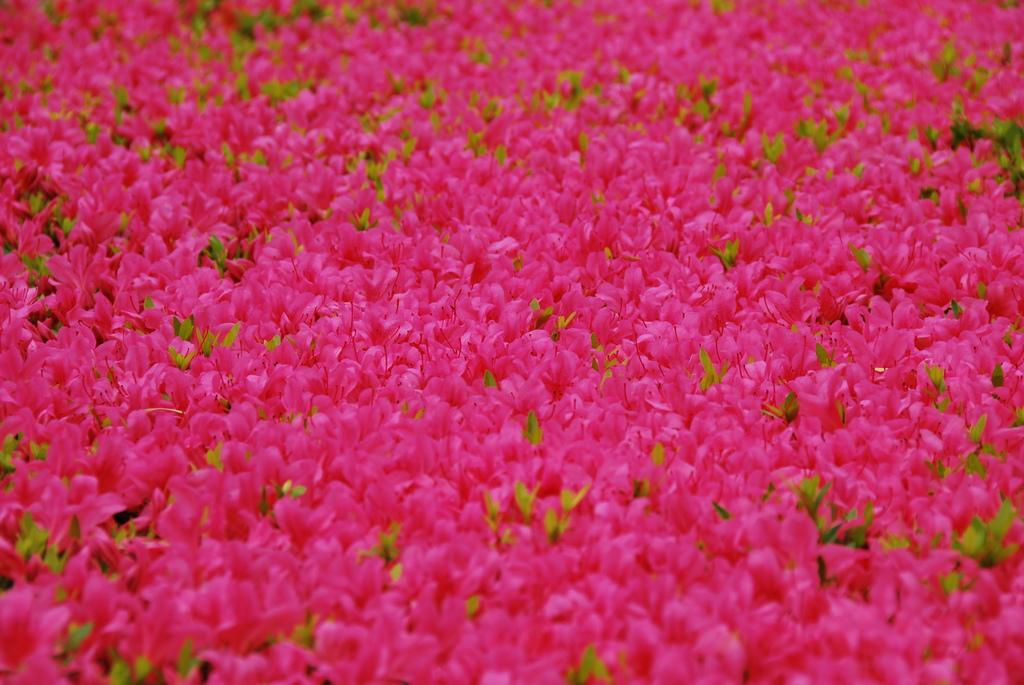What type of plant life is visible in the image? There are flowers and leaves in the image. What type of cherry can be seen growing on the flowers in the image? There are no cherries present in the image, and the flowers are not specified as cherry flowers. What effect does the presence of the flowers have on the overall aesthetic of the image? The provided facts do not include any information about the aesthetic impact of the flowers in the image. How many toes can be seen in the image? There are no toes visible in the image. 